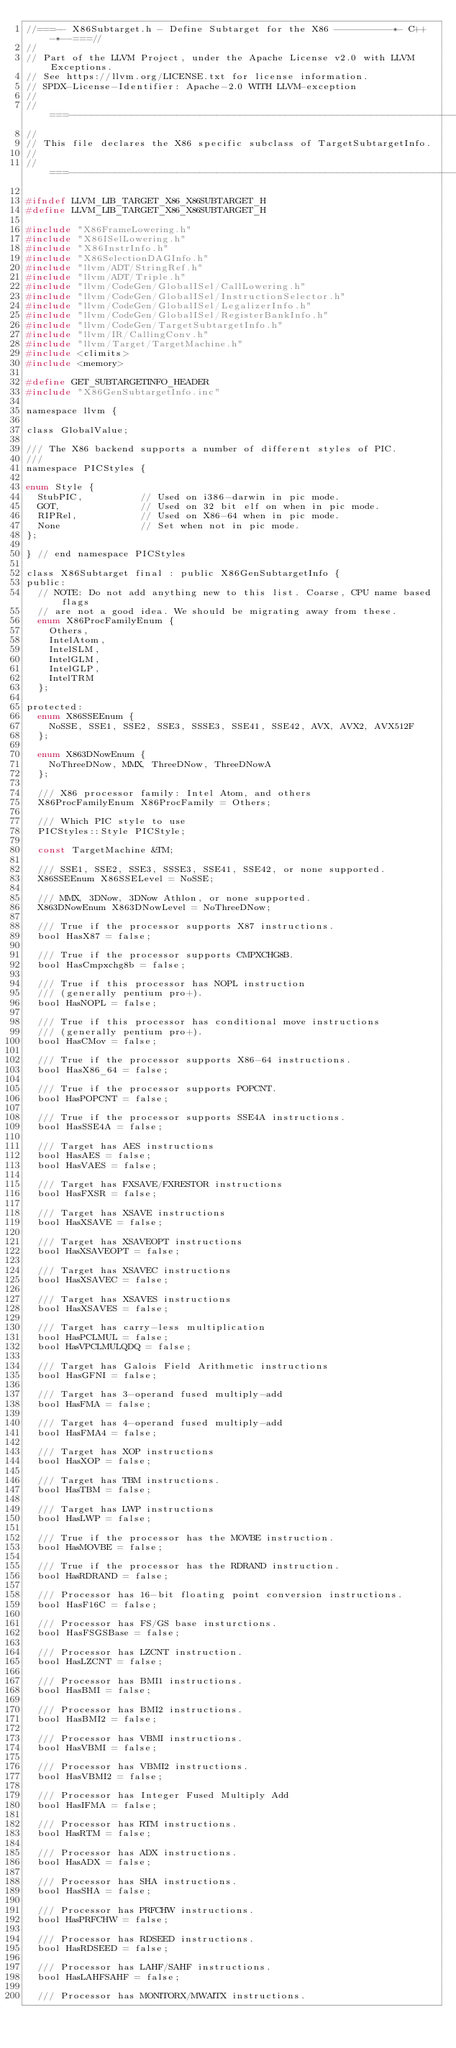Convert code to text. <code><loc_0><loc_0><loc_500><loc_500><_C_>//===-- X86Subtarget.h - Define Subtarget for the X86 ----------*- C++ -*--===//
//
// Part of the LLVM Project, under the Apache License v2.0 with LLVM Exceptions.
// See https://llvm.org/LICENSE.txt for license information.
// SPDX-License-Identifier: Apache-2.0 WITH LLVM-exception
//
//===----------------------------------------------------------------------===//
//
// This file declares the X86 specific subclass of TargetSubtargetInfo.
//
//===----------------------------------------------------------------------===//

#ifndef LLVM_LIB_TARGET_X86_X86SUBTARGET_H
#define LLVM_LIB_TARGET_X86_X86SUBTARGET_H

#include "X86FrameLowering.h"
#include "X86ISelLowering.h"
#include "X86InstrInfo.h"
#include "X86SelectionDAGInfo.h"
#include "llvm/ADT/StringRef.h"
#include "llvm/ADT/Triple.h"
#include "llvm/CodeGen/GlobalISel/CallLowering.h"
#include "llvm/CodeGen/GlobalISel/InstructionSelector.h"
#include "llvm/CodeGen/GlobalISel/LegalizerInfo.h"
#include "llvm/CodeGen/GlobalISel/RegisterBankInfo.h"
#include "llvm/CodeGen/TargetSubtargetInfo.h"
#include "llvm/IR/CallingConv.h"
#include "llvm/Target/TargetMachine.h"
#include <climits>
#include <memory>

#define GET_SUBTARGETINFO_HEADER
#include "X86GenSubtargetInfo.inc"

namespace llvm {

class GlobalValue;

/// The X86 backend supports a number of different styles of PIC.
///
namespace PICStyles {

enum Style {
  StubPIC,          // Used on i386-darwin in pic mode.
  GOT,              // Used on 32 bit elf on when in pic mode.
  RIPRel,           // Used on X86-64 when in pic mode.
  None              // Set when not in pic mode.
};

} // end namespace PICStyles

class X86Subtarget final : public X86GenSubtargetInfo {
public:
  // NOTE: Do not add anything new to this list. Coarse, CPU name based flags
  // are not a good idea. We should be migrating away from these.
  enum X86ProcFamilyEnum {
    Others,
    IntelAtom,
    IntelSLM,
    IntelGLM,
    IntelGLP,
    IntelTRM
  };

protected:
  enum X86SSEEnum {
    NoSSE, SSE1, SSE2, SSE3, SSSE3, SSE41, SSE42, AVX, AVX2, AVX512F
  };

  enum X863DNowEnum {
    NoThreeDNow, MMX, ThreeDNow, ThreeDNowA
  };

  /// X86 processor family: Intel Atom, and others
  X86ProcFamilyEnum X86ProcFamily = Others;

  /// Which PIC style to use
  PICStyles::Style PICStyle;

  const TargetMachine &TM;

  /// SSE1, SSE2, SSE3, SSSE3, SSE41, SSE42, or none supported.
  X86SSEEnum X86SSELevel = NoSSE;

  /// MMX, 3DNow, 3DNow Athlon, or none supported.
  X863DNowEnum X863DNowLevel = NoThreeDNow;

  /// True if the processor supports X87 instructions.
  bool HasX87 = false;

  /// True if the processor supports CMPXCHG8B.
  bool HasCmpxchg8b = false;

  /// True if this processor has NOPL instruction
  /// (generally pentium pro+).
  bool HasNOPL = false;

  /// True if this processor has conditional move instructions
  /// (generally pentium pro+).
  bool HasCMov = false;

  /// True if the processor supports X86-64 instructions.
  bool HasX86_64 = false;

  /// True if the processor supports POPCNT.
  bool HasPOPCNT = false;

  /// True if the processor supports SSE4A instructions.
  bool HasSSE4A = false;

  /// Target has AES instructions
  bool HasAES = false;
  bool HasVAES = false;

  /// Target has FXSAVE/FXRESTOR instructions
  bool HasFXSR = false;

  /// Target has XSAVE instructions
  bool HasXSAVE = false;

  /// Target has XSAVEOPT instructions
  bool HasXSAVEOPT = false;

  /// Target has XSAVEC instructions
  bool HasXSAVEC = false;

  /// Target has XSAVES instructions
  bool HasXSAVES = false;

  /// Target has carry-less multiplication
  bool HasPCLMUL = false;
  bool HasVPCLMULQDQ = false;

  /// Target has Galois Field Arithmetic instructions
  bool HasGFNI = false;

  /// Target has 3-operand fused multiply-add
  bool HasFMA = false;

  /// Target has 4-operand fused multiply-add
  bool HasFMA4 = false;

  /// Target has XOP instructions
  bool HasXOP = false;

  /// Target has TBM instructions.
  bool HasTBM = false;

  /// Target has LWP instructions
  bool HasLWP = false;

  /// True if the processor has the MOVBE instruction.
  bool HasMOVBE = false;

  /// True if the processor has the RDRAND instruction.
  bool HasRDRAND = false;

  /// Processor has 16-bit floating point conversion instructions.
  bool HasF16C = false;

  /// Processor has FS/GS base insturctions.
  bool HasFSGSBase = false;

  /// Processor has LZCNT instruction.
  bool HasLZCNT = false;

  /// Processor has BMI1 instructions.
  bool HasBMI = false;

  /// Processor has BMI2 instructions.
  bool HasBMI2 = false;

  /// Processor has VBMI instructions.
  bool HasVBMI = false;

  /// Processor has VBMI2 instructions.
  bool HasVBMI2 = false;

  /// Processor has Integer Fused Multiply Add
  bool HasIFMA = false;

  /// Processor has RTM instructions.
  bool HasRTM = false;

  /// Processor has ADX instructions.
  bool HasADX = false;

  /// Processor has SHA instructions.
  bool HasSHA = false;

  /// Processor has PRFCHW instructions.
  bool HasPRFCHW = false;

  /// Processor has RDSEED instructions.
  bool HasRDSEED = false;

  /// Processor has LAHF/SAHF instructions.
  bool HasLAHFSAHF = false;

  /// Processor has MONITORX/MWAITX instructions.</code> 